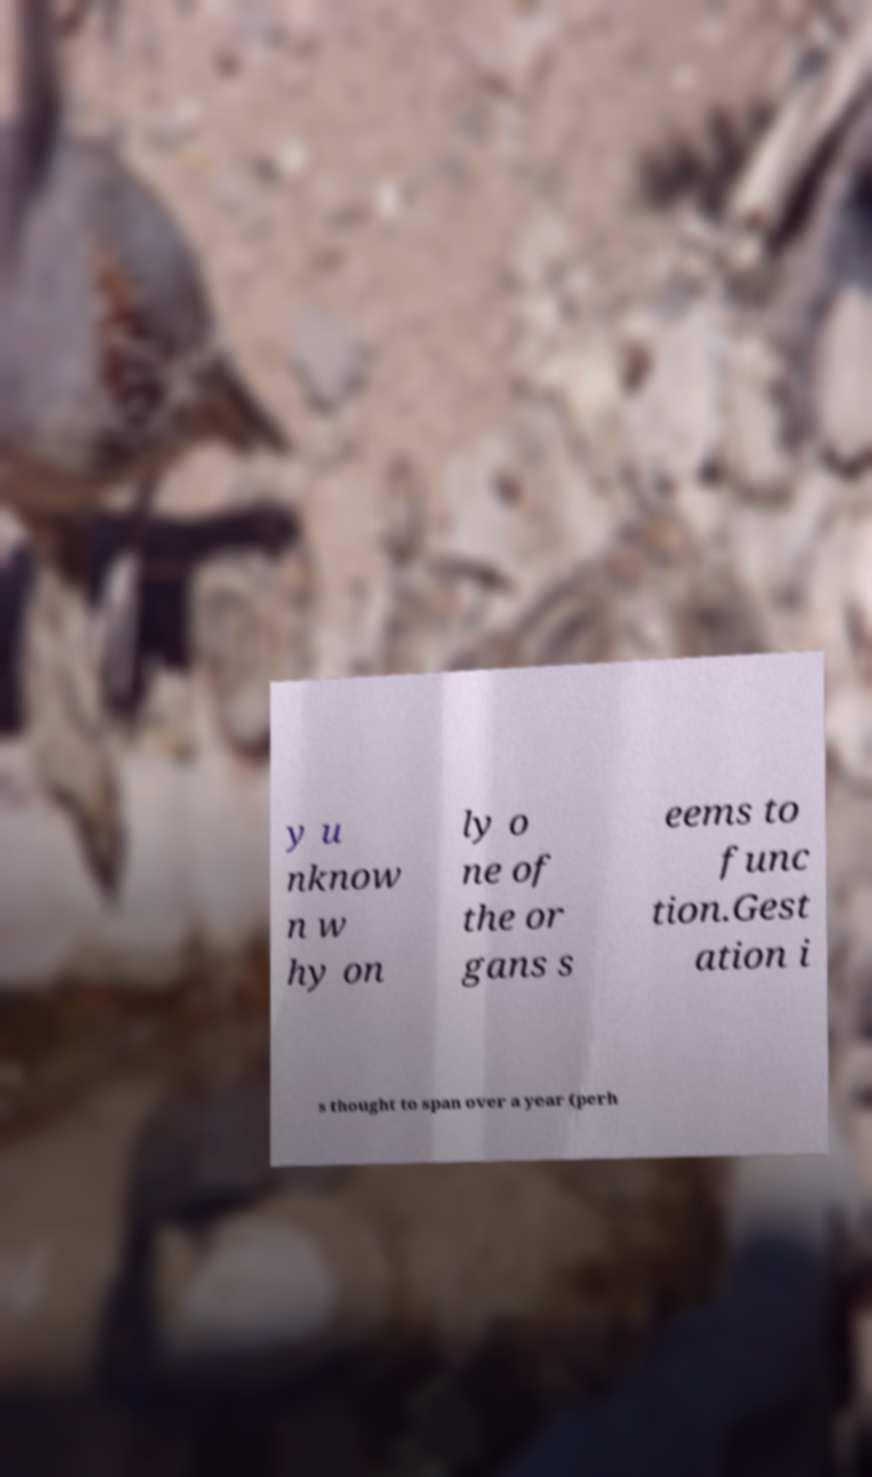For documentation purposes, I need the text within this image transcribed. Could you provide that? y u nknow n w hy on ly o ne of the or gans s eems to func tion.Gest ation i s thought to span over a year (perh 